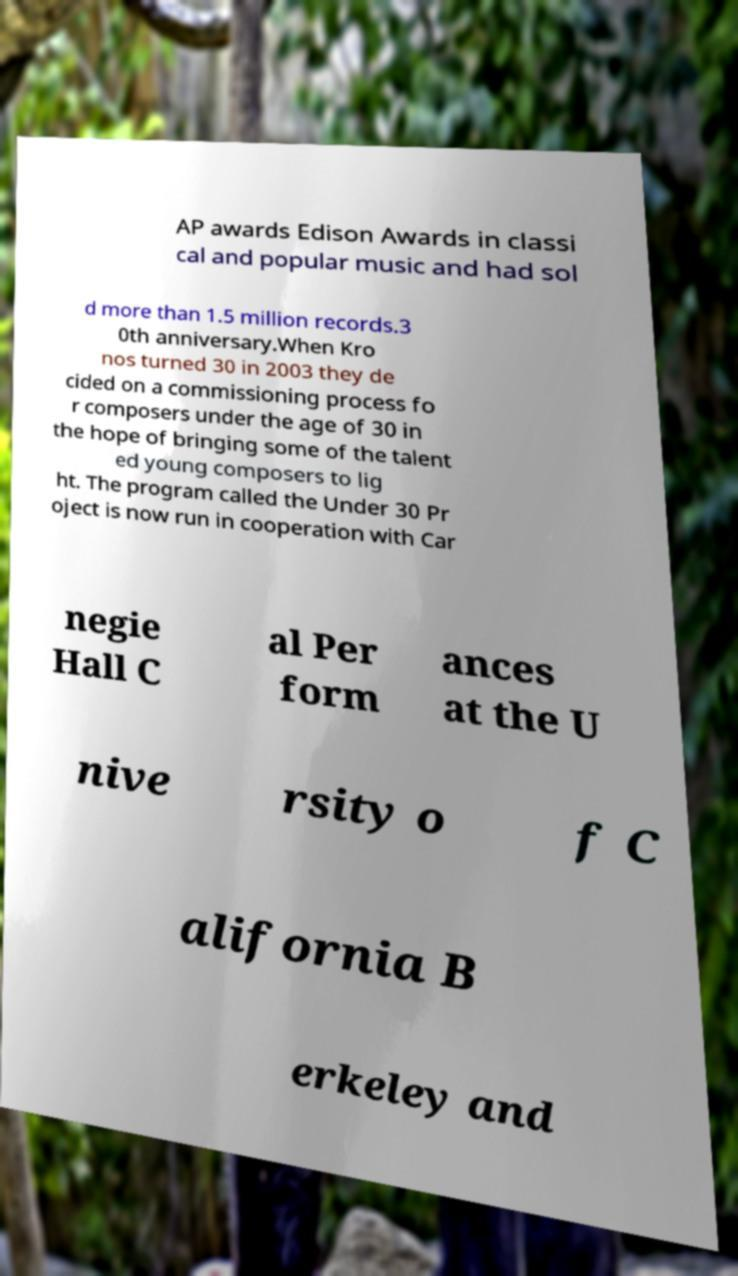I need the written content from this picture converted into text. Can you do that? AP awards Edison Awards in classi cal and popular music and had sol d more than 1.5 million records.3 0th anniversary.When Kro nos turned 30 in 2003 they de cided on a commissioning process fo r composers under the age of 30 in the hope of bringing some of the talent ed young composers to lig ht. The program called the Under 30 Pr oject is now run in cooperation with Car negie Hall C al Per form ances at the U nive rsity o f C alifornia B erkeley and 